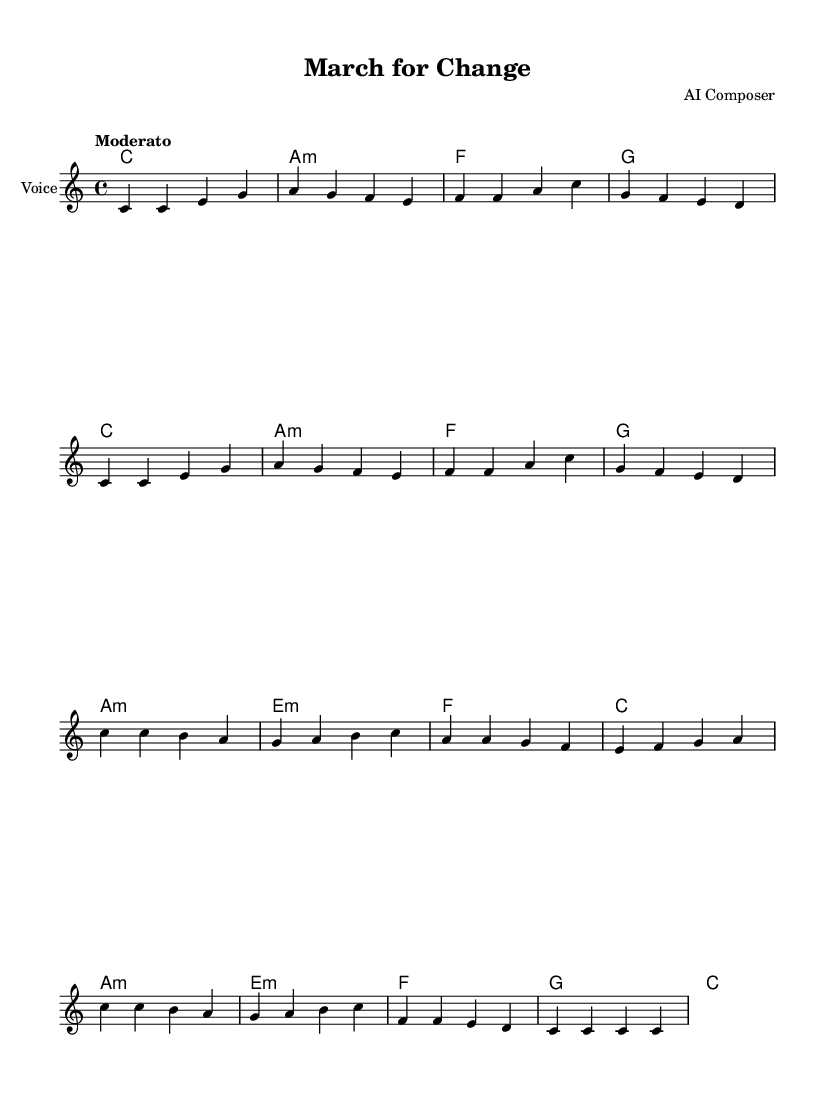What is the key signature of this music? The key signature is indicated in the global settings at the beginning of the code, which shows "C major" and is represented visually with no sharps or flats on the staff.
Answer: C major What is the time signature of this music? The time signature is also set in the global section of the code and is shown as "4/4," which means there are four beats in each measure and a quarter note gets one beat.
Answer: 4/4 What is the tempo marking for this piece? The tempo marking "Moderato" is provided in the global section and indicates a moderate speed for the music, guiding the performer on how quickly to play.
Answer: Moderato How many measures are in the music? By counting the number of measure bars in the provided music notes and chord progression, we find there are eight measures in total.
Answer: 8 What is the title of the song? The title is specified in the header of the code as "March for Change," referring to the overall theme and message of the song.
Answer: March for Change What musical form does this piece follow based on its structure? The structure consists of repeated sections in both the voice and the guitar chords, suggesting a strophic form, common in protest songs for easy memorization and participation.
Answer: Strophic 